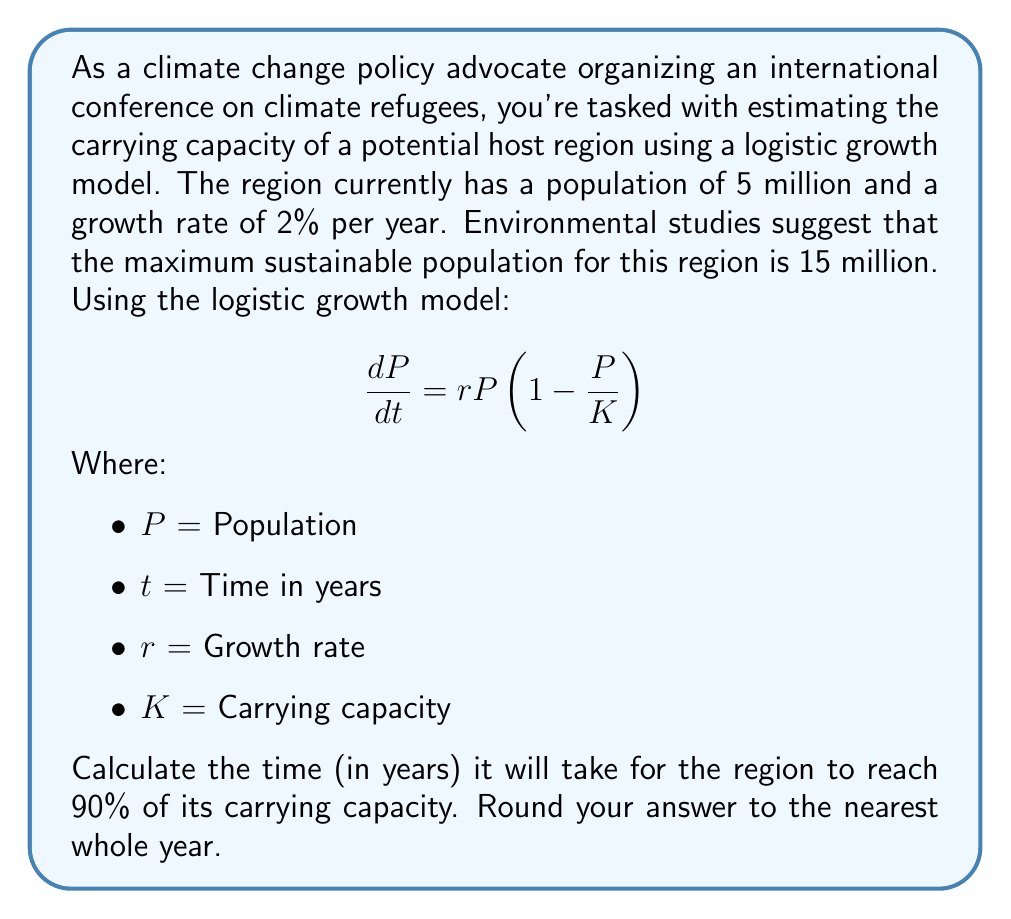Solve this math problem. Let's approach this step-by-step:

1) We're given:
   - Initial population, $P_0 = 5$ million
   - Growth rate, $r = 0.02$ (2% per year)
   - Carrying capacity, $K = 15$ million
   - We need to find when population reaches 90% of K, i.e., $P = 0.9K = 13.5$ million

2) The solution to the logistic growth model is:

   $$P(t) = \frac{K}{1 + (\frac{K}{P_0} - 1)e^{-rt}}$$

3) We want to find $t$ when $P(t) = 13.5$ million. Let's substitute our known values:

   $$13.5 = \frac{15}{1 + (\frac{15}{5} - 1)e^{-0.02t}}$$

4) Simplify:
   
   $$13.5 = \frac{15}{1 + 2e^{-0.02t}}$$

5) Multiply both sides by $(1 + 2e^{-0.02t})$:

   $$13.5 + 27e^{-0.02t} = 15$$

6) Subtract 13.5 from both sides:

   $$27e^{-0.02t} = 1.5$$

7) Divide both sides by 27:

   $$e^{-0.02t} = \frac{1.5}{27} = \frac{1}{18}$$

8) Take the natural log of both sides:

   $$-0.02t = \ln(\frac{1}{18}) = -\ln(18)$$

9) Divide both sides by -0.02:

   $$t = \frac{\ln(18)}{0.02} \approx 144.8$$

10) Rounding to the nearest whole year:

    $$t \approx 145 \text{ years}$$
Answer: 145 years 